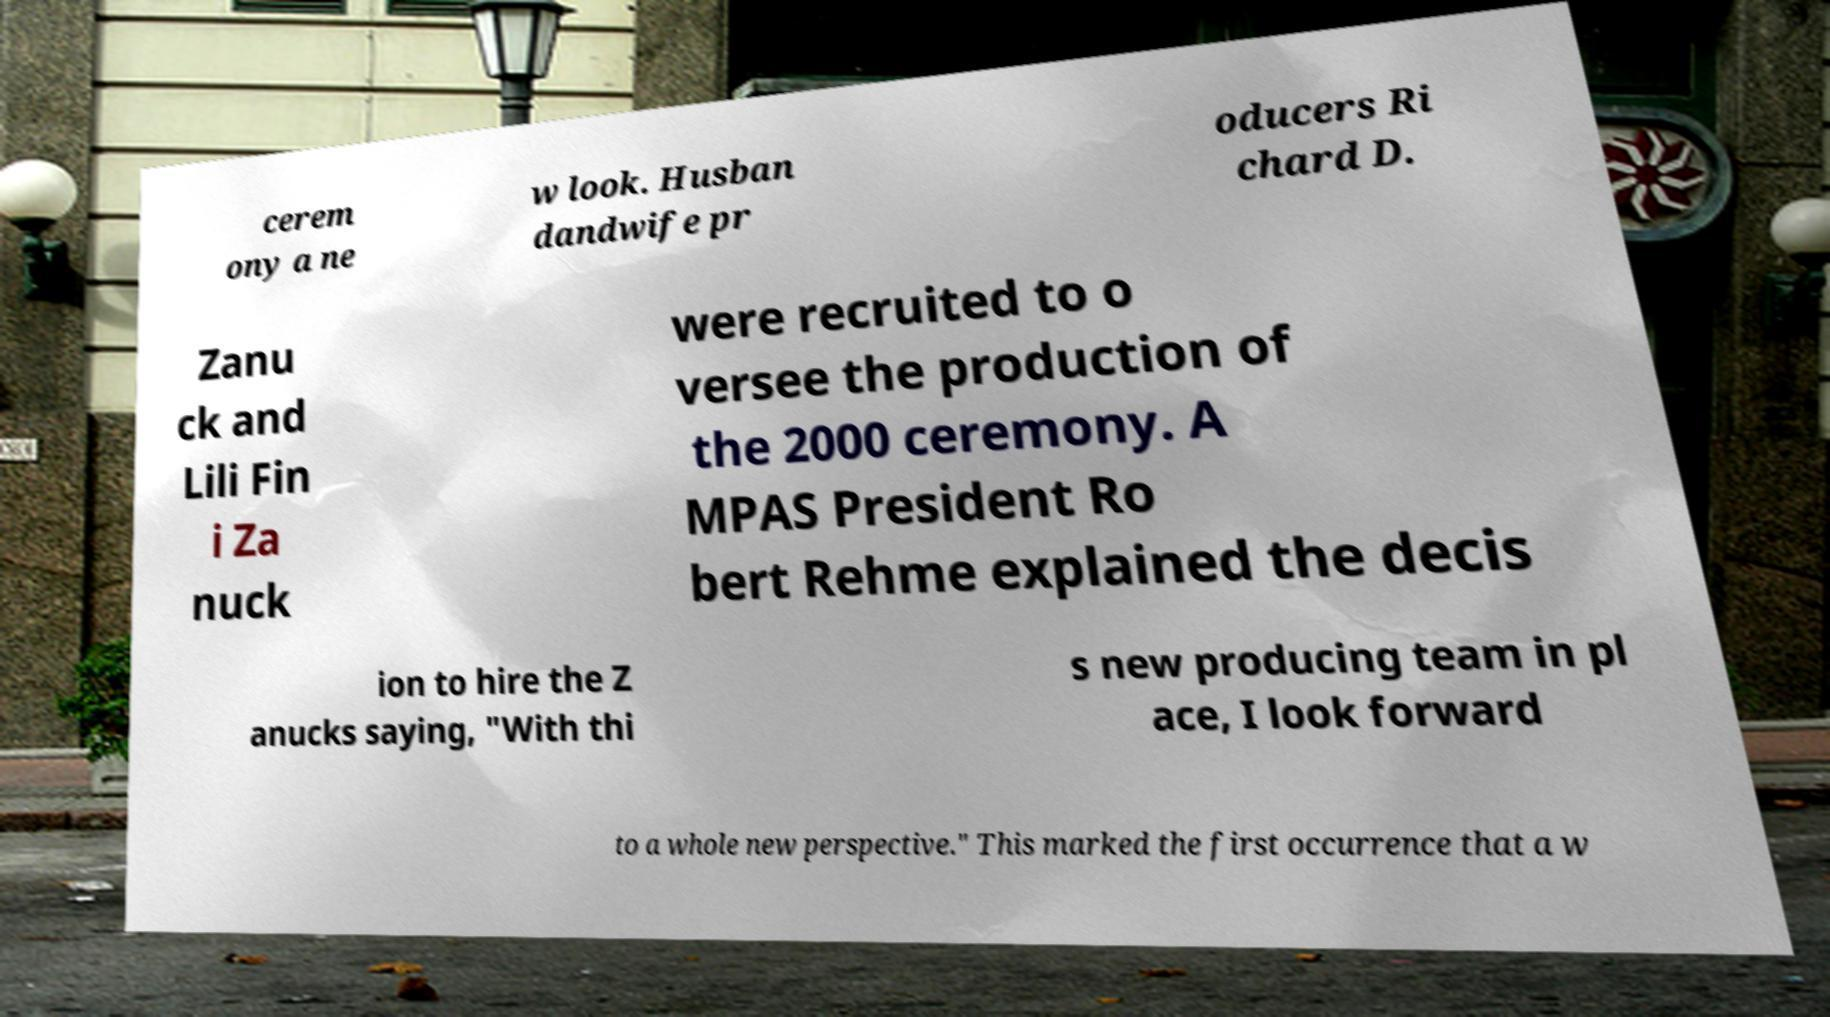Could you assist in decoding the text presented in this image and type it out clearly? cerem ony a ne w look. Husban dandwife pr oducers Ri chard D. Zanu ck and Lili Fin i Za nuck were recruited to o versee the production of the 2000 ceremony. A MPAS President Ro bert Rehme explained the decis ion to hire the Z anucks saying, "With thi s new producing team in pl ace, I look forward to a whole new perspective." This marked the first occurrence that a w 